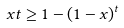<formula> <loc_0><loc_0><loc_500><loc_500>x t \geq 1 - ( 1 - x ) ^ { t }</formula> 